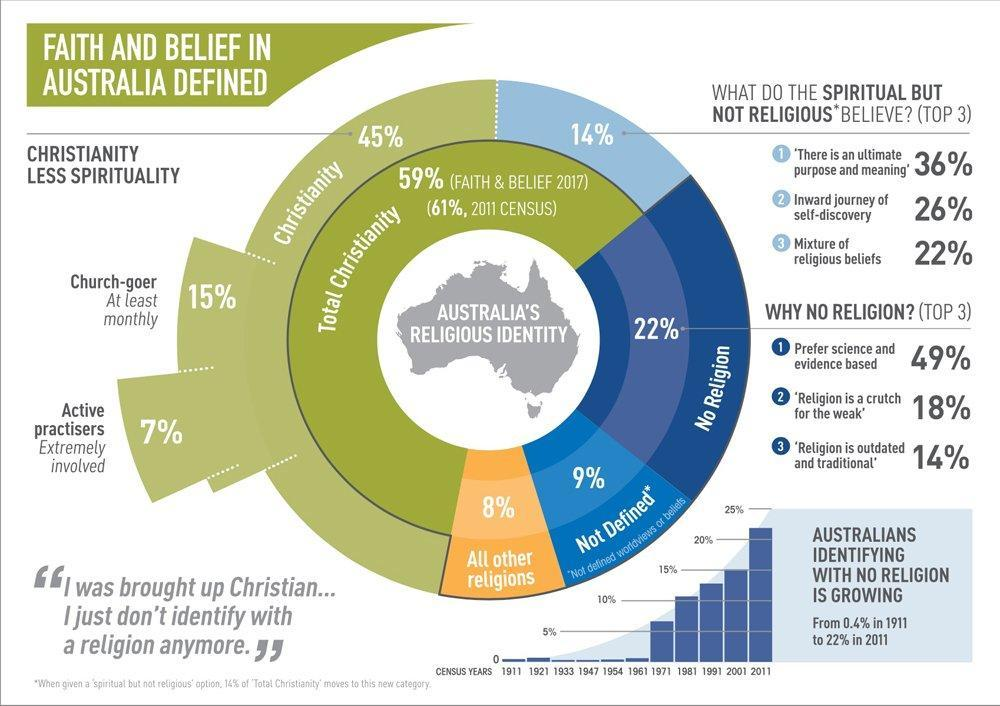what has been the percentage in 2001?
Answer the question with a short phrase. 15% what is the second reason for not following any religion? religion is a crutch for the weak What is the total percentage of church-goers and active practisers 22 which religion has the most number of followers total christianity in the past 100 years, what has the increase in percentage been of australians not identifying with any religion 21.6 what is the total percentage of all other religions and religions not defined 17 